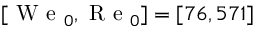<formula> <loc_0><loc_0><loc_500><loc_500>[ W e _ { 0 } , R e _ { 0 } ] = [ 7 6 , 5 7 1 ]</formula> 